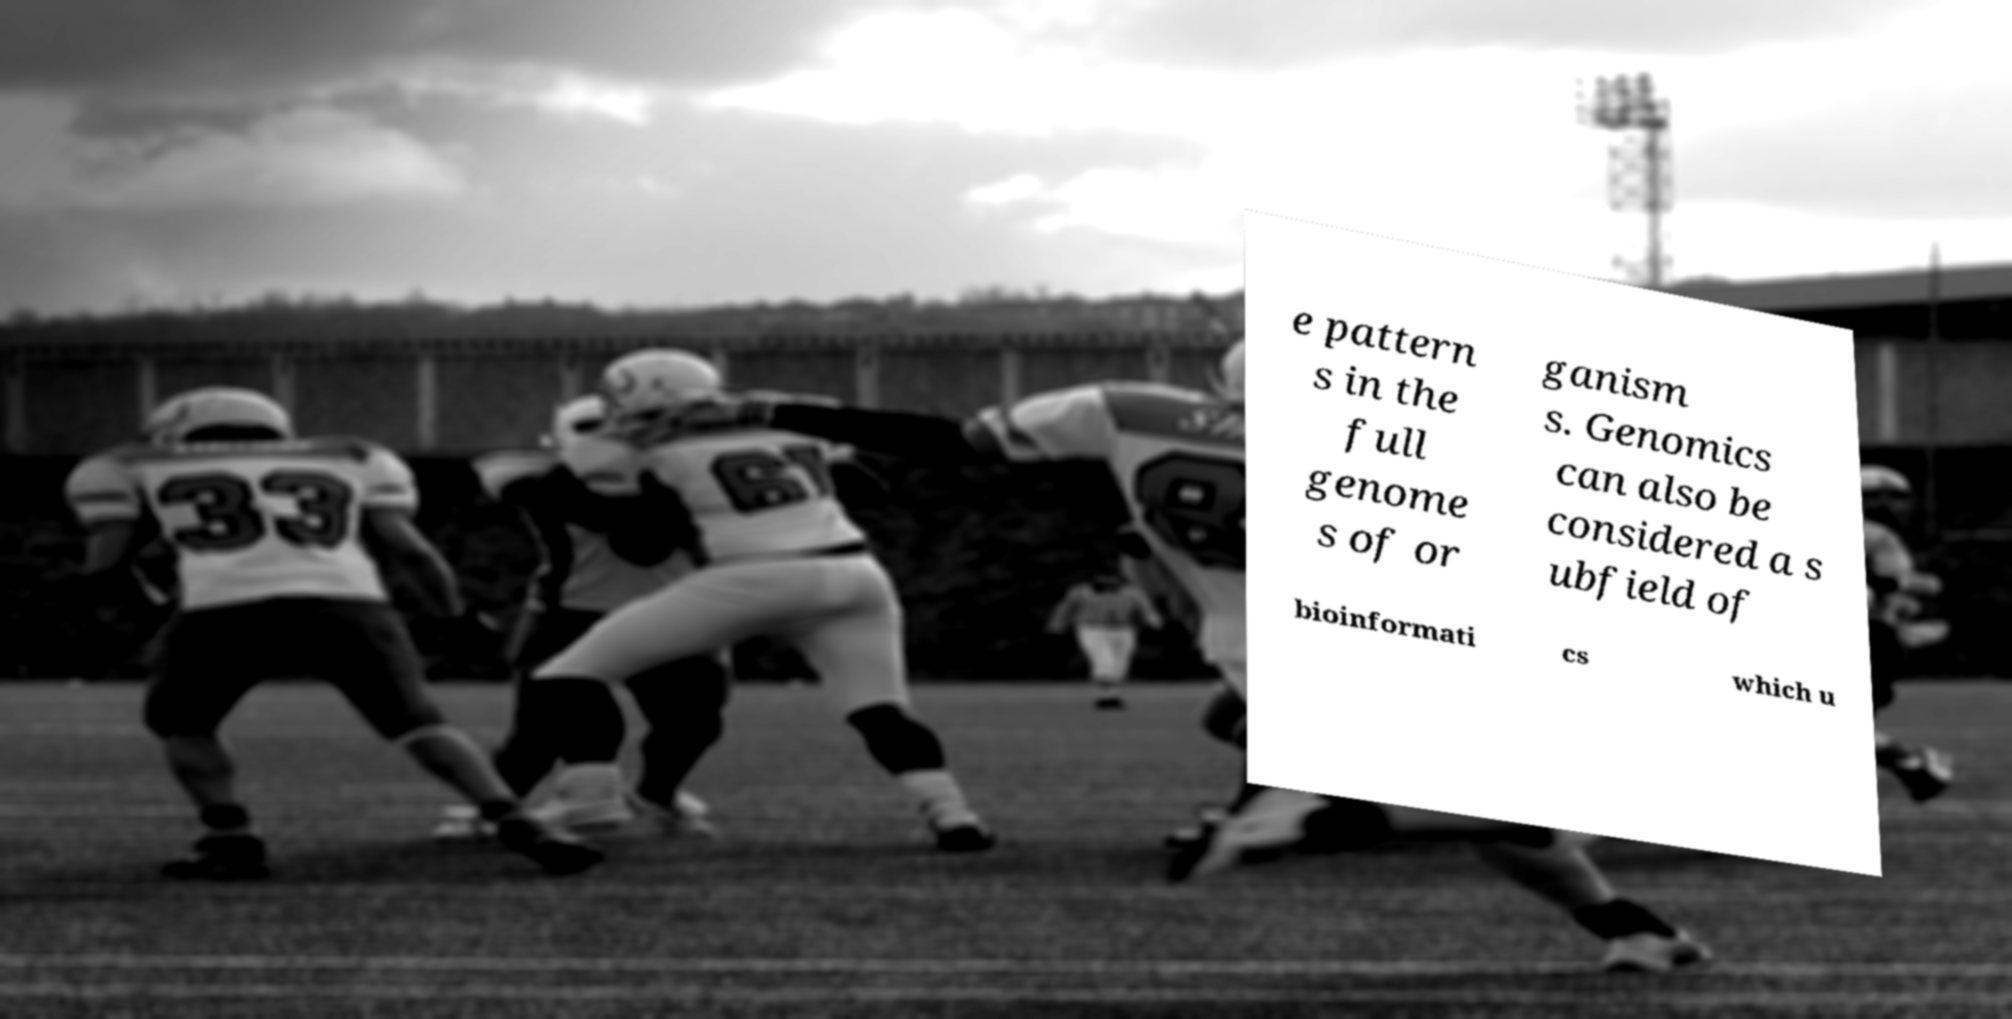Please read and relay the text visible in this image. What does it say? e pattern s in the full genome s of or ganism s. Genomics can also be considered a s ubfield of bioinformati cs which u 